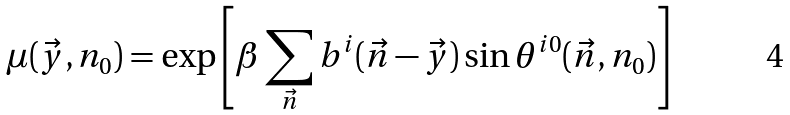Convert formula to latex. <formula><loc_0><loc_0><loc_500><loc_500>\mu ( \vec { y } , n _ { 0 } ) = \exp \left [ \beta \sum _ { \vec { n } } b ^ { i } ( \vec { n } - \vec { y } ) \sin \theta ^ { i 0 } ( \vec { n } , n _ { 0 } ) \right ]</formula> 